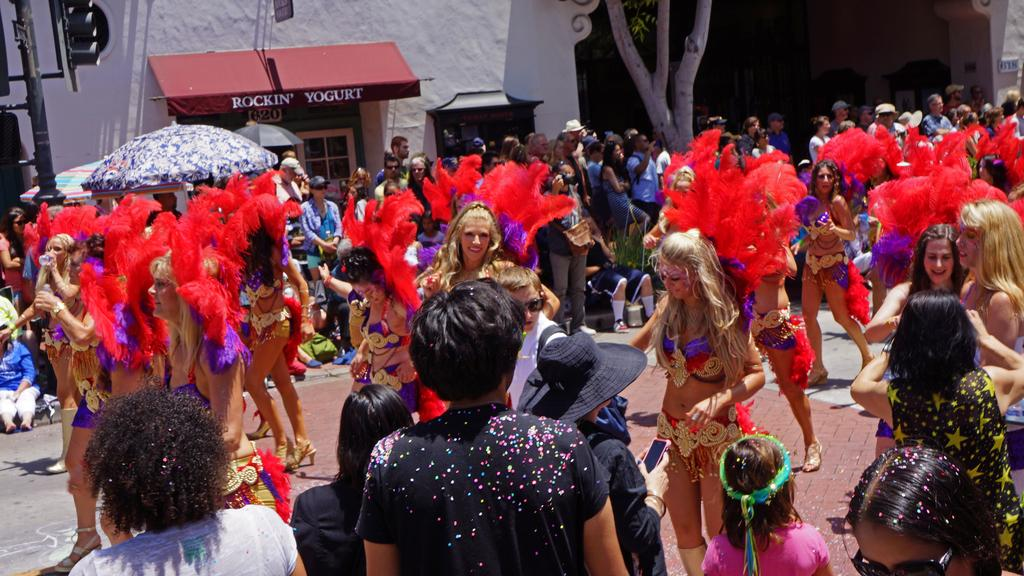What is the main subject of the image? The main subject of the image is a group of women. What are the women wearing in the image? The women are wearing different costumes in the image. What are the women doing in the image? The women are dancing in the image. Are there any other people present in the image? Yes, there are people standing around the group of women. What can be seen in the background of the image? There are houses and trees in the background of the image. Where is the nest located in the image? There is no nest present in the image. What type of advertisement can be seen on the costumes of the women? There is no advertisement visible on the costumes of the women in the image. 